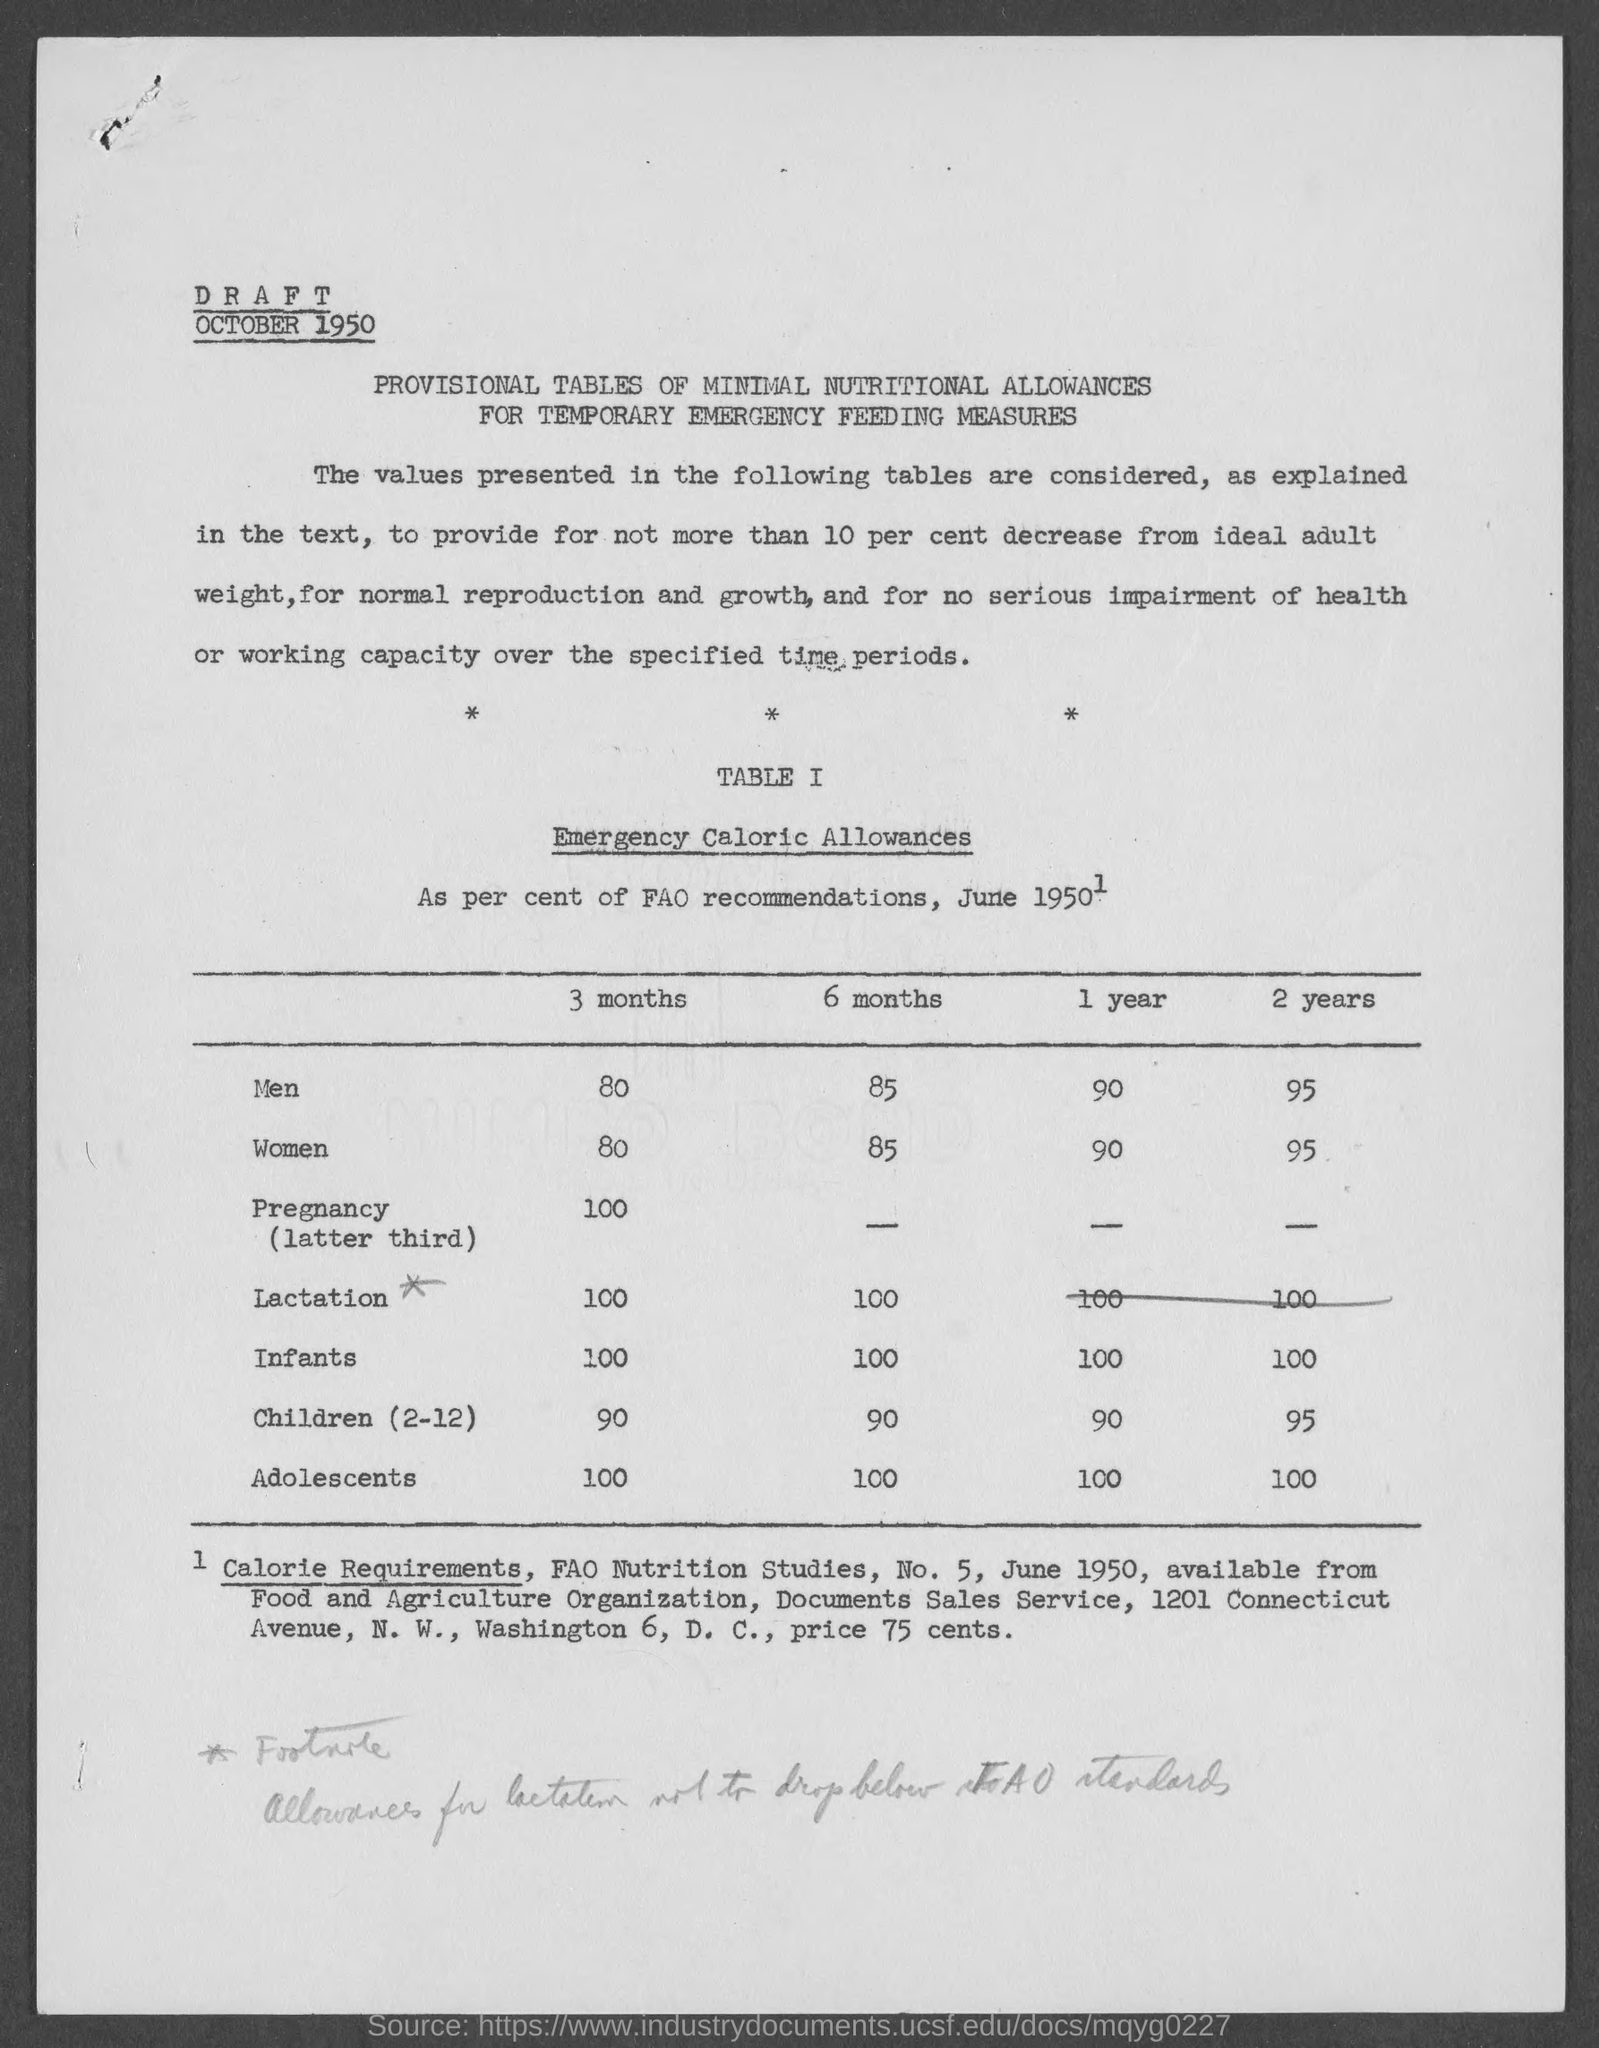What is the Emergency Caloric Allowance for men for 3 months?
Offer a terse response. 80. What is the Emergency Caloric Allowance for men for 6 months?
Keep it short and to the point. 85. What is the Emergency Caloric Allowance for men for 1 year?
Offer a very short reply. 90. What is the Emergency Caloric Allowance for men for 2 years?
Provide a succinct answer. 95. What is the Emergency Caloric Allowance for Women for 3 months?
Your response must be concise. 80. What is the Emergency Caloric Allowance for Women for 6 months?
Offer a very short reply. 85. What is the Emergency Caloric Allowance for Women for 1 year?
Provide a short and direct response. 90. What is the Emergency Caloric Allowance for Women for 2 years?
Keep it short and to the point. 95. 